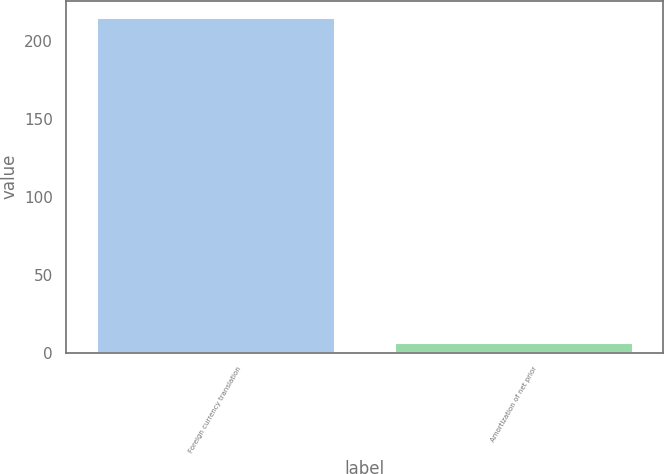<chart> <loc_0><loc_0><loc_500><loc_500><bar_chart><fcel>Foreign currency translation<fcel>Amortization of net prior<nl><fcel>214.9<fcel>6.7<nl></chart> 